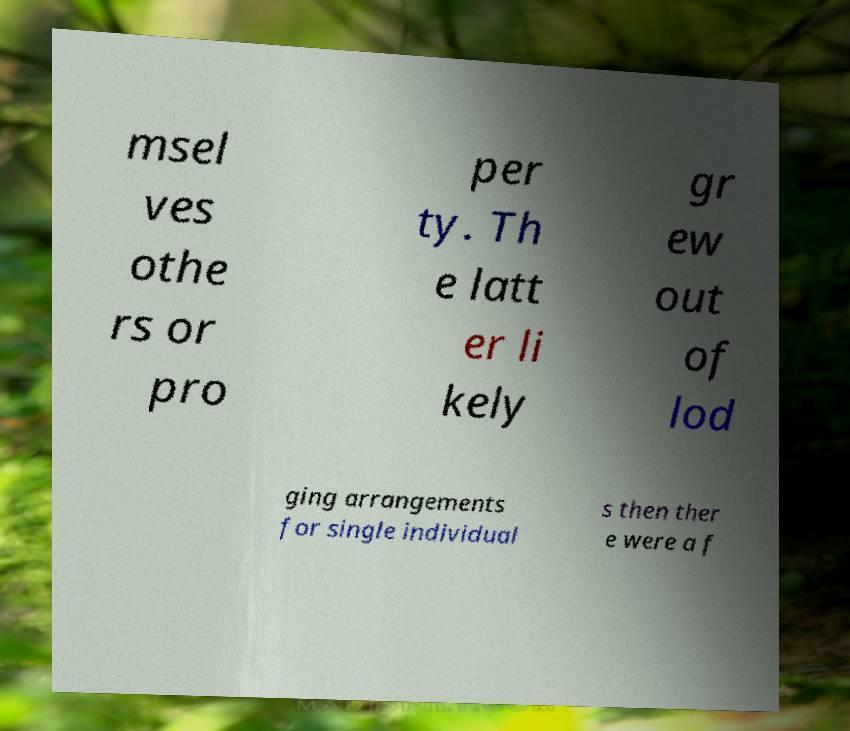For documentation purposes, I need the text within this image transcribed. Could you provide that? msel ves othe rs or pro per ty. Th e latt er li kely gr ew out of lod ging arrangements for single individual s then ther e were a f 